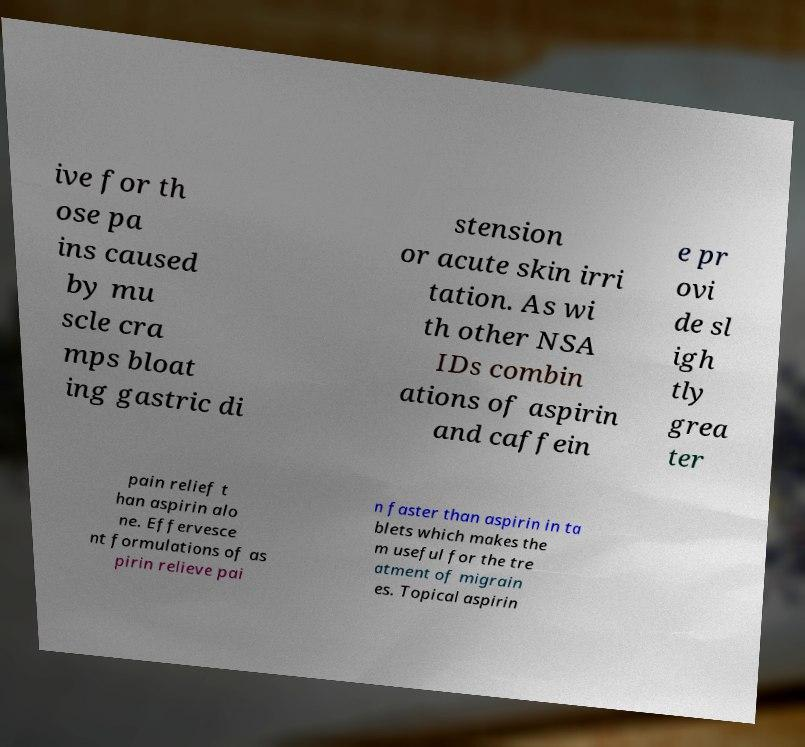Can you read and provide the text displayed in the image?This photo seems to have some interesting text. Can you extract and type it out for me? ive for th ose pa ins caused by mu scle cra mps bloat ing gastric di stension or acute skin irri tation. As wi th other NSA IDs combin ations of aspirin and caffein e pr ovi de sl igh tly grea ter pain relief t han aspirin alo ne. Effervesce nt formulations of as pirin relieve pai n faster than aspirin in ta blets which makes the m useful for the tre atment of migrain es. Topical aspirin 